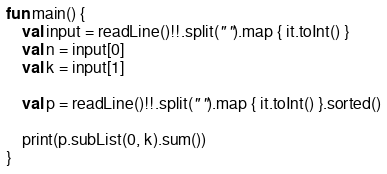Convert code to text. <code><loc_0><loc_0><loc_500><loc_500><_Kotlin_>fun main() {
    val input = readLine()!!.split(" ").map { it.toInt() }
    val n = input[0]
    val k = input[1]

    val p = readLine()!!.split(" ").map { it.toInt() }.sorted()

    print(p.subList(0, k).sum())
}</code> 